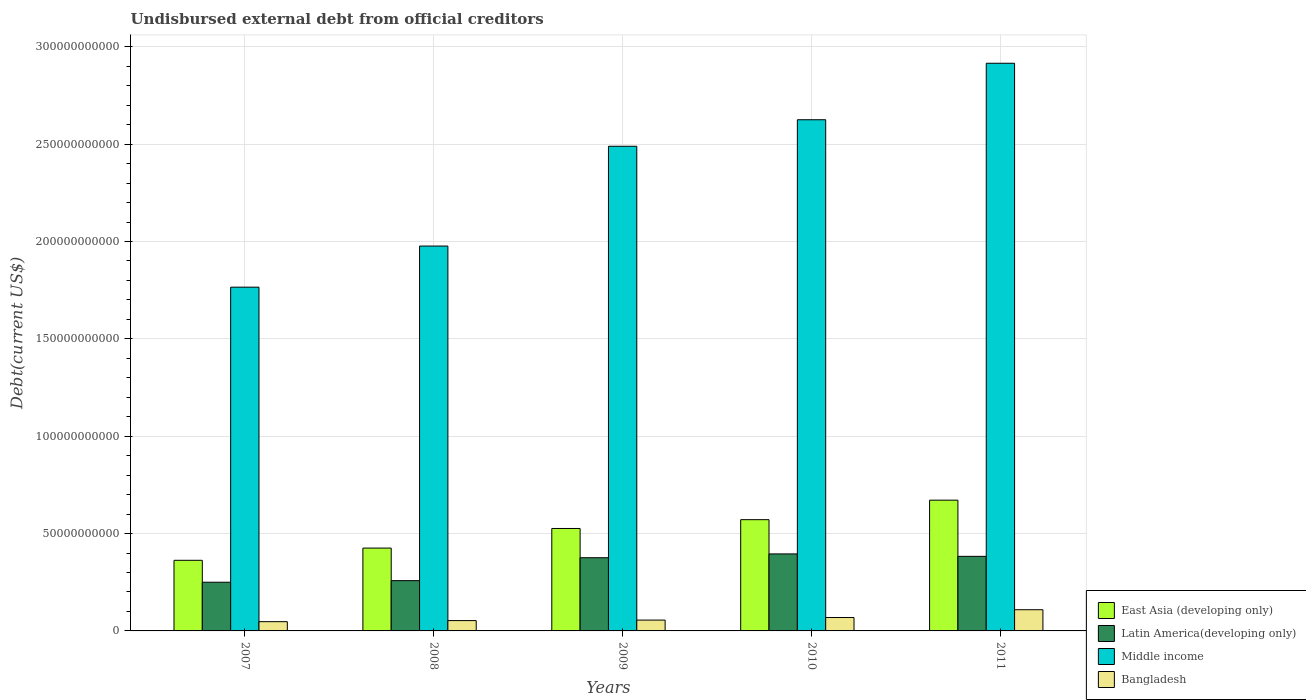How many groups of bars are there?
Keep it short and to the point. 5. How many bars are there on the 2nd tick from the right?
Offer a terse response. 4. In how many cases, is the number of bars for a given year not equal to the number of legend labels?
Ensure brevity in your answer.  0. What is the total debt in East Asia (developing only) in 2007?
Your response must be concise. 3.63e+1. Across all years, what is the maximum total debt in Latin America(developing only)?
Offer a terse response. 3.95e+1. Across all years, what is the minimum total debt in East Asia (developing only)?
Keep it short and to the point. 3.63e+1. In which year was the total debt in Middle income minimum?
Ensure brevity in your answer.  2007. What is the total total debt in Middle income in the graph?
Give a very brief answer. 1.18e+12. What is the difference between the total debt in Bangladesh in 2007 and that in 2010?
Offer a terse response. -2.13e+09. What is the difference between the total debt in East Asia (developing only) in 2011 and the total debt in Bangladesh in 2007?
Give a very brief answer. 6.24e+1. What is the average total debt in East Asia (developing only) per year?
Make the answer very short. 5.11e+1. In the year 2007, what is the difference between the total debt in Middle income and total debt in East Asia (developing only)?
Keep it short and to the point. 1.40e+11. What is the ratio of the total debt in Middle income in 2007 to that in 2010?
Give a very brief answer. 0.67. What is the difference between the highest and the second highest total debt in Bangladesh?
Offer a terse response. 4.00e+09. What is the difference between the highest and the lowest total debt in East Asia (developing only)?
Ensure brevity in your answer.  3.09e+1. Is the sum of the total debt in Bangladesh in 2010 and 2011 greater than the maximum total debt in Latin America(developing only) across all years?
Make the answer very short. No. What does the 1st bar from the left in 2008 represents?
Offer a terse response. East Asia (developing only). What does the 4th bar from the right in 2009 represents?
Keep it short and to the point. East Asia (developing only). What is the difference between two consecutive major ticks on the Y-axis?
Give a very brief answer. 5.00e+1. Does the graph contain any zero values?
Give a very brief answer. No. Where does the legend appear in the graph?
Ensure brevity in your answer.  Bottom right. How many legend labels are there?
Provide a succinct answer. 4. What is the title of the graph?
Provide a short and direct response. Undisbursed external debt from official creditors. What is the label or title of the X-axis?
Give a very brief answer. Years. What is the label or title of the Y-axis?
Keep it short and to the point. Debt(current US$). What is the Debt(current US$) in East Asia (developing only) in 2007?
Offer a very short reply. 3.63e+1. What is the Debt(current US$) in Latin America(developing only) in 2007?
Give a very brief answer. 2.50e+1. What is the Debt(current US$) in Middle income in 2007?
Ensure brevity in your answer.  1.77e+11. What is the Debt(current US$) of Bangladesh in 2007?
Make the answer very short. 4.76e+09. What is the Debt(current US$) of East Asia (developing only) in 2008?
Provide a short and direct response. 4.25e+1. What is the Debt(current US$) of Latin America(developing only) in 2008?
Your answer should be very brief. 2.58e+1. What is the Debt(current US$) in Middle income in 2008?
Offer a very short reply. 1.98e+11. What is the Debt(current US$) of Bangladesh in 2008?
Give a very brief answer. 5.31e+09. What is the Debt(current US$) of East Asia (developing only) in 2009?
Make the answer very short. 5.26e+1. What is the Debt(current US$) of Latin America(developing only) in 2009?
Provide a short and direct response. 3.76e+1. What is the Debt(current US$) in Middle income in 2009?
Your answer should be very brief. 2.49e+11. What is the Debt(current US$) of Bangladesh in 2009?
Your response must be concise. 5.57e+09. What is the Debt(current US$) in East Asia (developing only) in 2010?
Your answer should be very brief. 5.71e+1. What is the Debt(current US$) in Latin America(developing only) in 2010?
Ensure brevity in your answer.  3.95e+1. What is the Debt(current US$) in Middle income in 2010?
Your answer should be compact. 2.63e+11. What is the Debt(current US$) in Bangladesh in 2010?
Give a very brief answer. 6.88e+09. What is the Debt(current US$) of East Asia (developing only) in 2011?
Make the answer very short. 6.71e+1. What is the Debt(current US$) in Latin America(developing only) in 2011?
Provide a short and direct response. 3.83e+1. What is the Debt(current US$) of Middle income in 2011?
Give a very brief answer. 2.92e+11. What is the Debt(current US$) in Bangladesh in 2011?
Keep it short and to the point. 1.09e+1. Across all years, what is the maximum Debt(current US$) in East Asia (developing only)?
Provide a short and direct response. 6.71e+1. Across all years, what is the maximum Debt(current US$) in Latin America(developing only)?
Offer a very short reply. 3.95e+1. Across all years, what is the maximum Debt(current US$) of Middle income?
Offer a very short reply. 2.92e+11. Across all years, what is the maximum Debt(current US$) in Bangladesh?
Offer a very short reply. 1.09e+1. Across all years, what is the minimum Debt(current US$) in East Asia (developing only)?
Make the answer very short. 3.63e+1. Across all years, what is the minimum Debt(current US$) in Latin America(developing only)?
Provide a short and direct response. 2.50e+1. Across all years, what is the minimum Debt(current US$) in Middle income?
Provide a succinct answer. 1.77e+11. Across all years, what is the minimum Debt(current US$) in Bangladesh?
Provide a succinct answer. 4.76e+09. What is the total Debt(current US$) of East Asia (developing only) in the graph?
Offer a very short reply. 2.56e+11. What is the total Debt(current US$) of Latin America(developing only) in the graph?
Keep it short and to the point. 1.66e+11. What is the total Debt(current US$) of Middle income in the graph?
Provide a short and direct response. 1.18e+12. What is the total Debt(current US$) in Bangladesh in the graph?
Offer a terse response. 3.34e+1. What is the difference between the Debt(current US$) in East Asia (developing only) in 2007 and that in 2008?
Offer a very short reply. -6.27e+09. What is the difference between the Debt(current US$) in Latin America(developing only) in 2007 and that in 2008?
Your response must be concise. -8.16e+08. What is the difference between the Debt(current US$) of Middle income in 2007 and that in 2008?
Give a very brief answer. -2.11e+1. What is the difference between the Debt(current US$) in Bangladesh in 2007 and that in 2008?
Offer a very short reply. -5.49e+08. What is the difference between the Debt(current US$) of East Asia (developing only) in 2007 and that in 2009?
Provide a succinct answer. -1.63e+1. What is the difference between the Debt(current US$) in Latin America(developing only) in 2007 and that in 2009?
Provide a short and direct response. -1.26e+1. What is the difference between the Debt(current US$) in Middle income in 2007 and that in 2009?
Keep it short and to the point. -7.24e+1. What is the difference between the Debt(current US$) of Bangladesh in 2007 and that in 2009?
Keep it short and to the point. -8.10e+08. What is the difference between the Debt(current US$) in East Asia (developing only) in 2007 and that in 2010?
Your answer should be very brief. -2.09e+1. What is the difference between the Debt(current US$) in Latin America(developing only) in 2007 and that in 2010?
Your answer should be compact. -1.45e+1. What is the difference between the Debt(current US$) in Middle income in 2007 and that in 2010?
Make the answer very short. -8.60e+1. What is the difference between the Debt(current US$) in Bangladesh in 2007 and that in 2010?
Offer a terse response. -2.13e+09. What is the difference between the Debt(current US$) in East Asia (developing only) in 2007 and that in 2011?
Offer a very short reply. -3.09e+1. What is the difference between the Debt(current US$) of Latin America(developing only) in 2007 and that in 2011?
Give a very brief answer. -1.33e+1. What is the difference between the Debt(current US$) in Middle income in 2007 and that in 2011?
Your response must be concise. -1.15e+11. What is the difference between the Debt(current US$) of Bangladesh in 2007 and that in 2011?
Provide a short and direct response. -6.13e+09. What is the difference between the Debt(current US$) in East Asia (developing only) in 2008 and that in 2009?
Your answer should be very brief. -1.01e+1. What is the difference between the Debt(current US$) of Latin America(developing only) in 2008 and that in 2009?
Your answer should be compact. -1.18e+1. What is the difference between the Debt(current US$) of Middle income in 2008 and that in 2009?
Keep it short and to the point. -5.12e+1. What is the difference between the Debt(current US$) in Bangladesh in 2008 and that in 2009?
Provide a short and direct response. -2.61e+08. What is the difference between the Debt(current US$) in East Asia (developing only) in 2008 and that in 2010?
Your answer should be very brief. -1.46e+1. What is the difference between the Debt(current US$) of Latin America(developing only) in 2008 and that in 2010?
Ensure brevity in your answer.  -1.37e+1. What is the difference between the Debt(current US$) in Middle income in 2008 and that in 2010?
Ensure brevity in your answer.  -6.49e+1. What is the difference between the Debt(current US$) in Bangladesh in 2008 and that in 2010?
Ensure brevity in your answer.  -1.58e+09. What is the difference between the Debt(current US$) in East Asia (developing only) in 2008 and that in 2011?
Your answer should be very brief. -2.46e+1. What is the difference between the Debt(current US$) of Latin America(developing only) in 2008 and that in 2011?
Ensure brevity in your answer.  -1.25e+1. What is the difference between the Debt(current US$) in Middle income in 2008 and that in 2011?
Provide a succinct answer. -9.39e+1. What is the difference between the Debt(current US$) in Bangladesh in 2008 and that in 2011?
Offer a terse response. -5.58e+09. What is the difference between the Debt(current US$) of East Asia (developing only) in 2009 and that in 2010?
Ensure brevity in your answer.  -4.53e+09. What is the difference between the Debt(current US$) in Latin America(developing only) in 2009 and that in 2010?
Ensure brevity in your answer.  -1.96e+09. What is the difference between the Debt(current US$) in Middle income in 2009 and that in 2010?
Your answer should be very brief. -1.36e+1. What is the difference between the Debt(current US$) in Bangladesh in 2009 and that in 2010?
Offer a terse response. -1.32e+09. What is the difference between the Debt(current US$) of East Asia (developing only) in 2009 and that in 2011?
Offer a very short reply. -1.45e+1. What is the difference between the Debt(current US$) in Latin America(developing only) in 2009 and that in 2011?
Keep it short and to the point. -7.08e+08. What is the difference between the Debt(current US$) of Middle income in 2009 and that in 2011?
Provide a succinct answer. -4.26e+1. What is the difference between the Debt(current US$) in Bangladesh in 2009 and that in 2011?
Give a very brief answer. -5.32e+09. What is the difference between the Debt(current US$) of East Asia (developing only) in 2010 and that in 2011?
Make the answer very short. -1.00e+1. What is the difference between the Debt(current US$) of Latin America(developing only) in 2010 and that in 2011?
Your answer should be compact. 1.25e+09. What is the difference between the Debt(current US$) in Middle income in 2010 and that in 2011?
Provide a succinct answer. -2.90e+1. What is the difference between the Debt(current US$) of Bangladesh in 2010 and that in 2011?
Your answer should be compact. -4.00e+09. What is the difference between the Debt(current US$) of East Asia (developing only) in 2007 and the Debt(current US$) of Latin America(developing only) in 2008?
Provide a short and direct response. 1.04e+1. What is the difference between the Debt(current US$) of East Asia (developing only) in 2007 and the Debt(current US$) of Middle income in 2008?
Offer a terse response. -1.61e+11. What is the difference between the Debt(current US$) in East Asia (developing only) in 2007 and the Debt(current US$) in Bangladesh in 2008?
Provide a succinct answer. 3.10e+1. What is the difference between the Debt(current US$) in Latin America(developing only) in 2007 and the Debt(current US$) in Middle income in 2008?
Your answer should be very brief. -1.73e+11. What is the difference between the Debt(current US$) in Latin America(developing only) in 2007 and the Debt(current US$) in Bangladesh in 2008?
Give a very brief answer. 1.97e+1. What is the difference between the Debt(current US$) in Middle income in 2007 and the Debt(current US$) in Bangladesh in 2008?
Your answer should be very brief. 1.71e+11. What is the difference between the Debt(current US$) in East Asia (developing only) in 2007 and the Debt(current US$) in Latin America(developing only) in 2009?
Your answer should be very brief. -1.32e+09. What is the difference between the Debt(current US$) of East Asia (developing only) in 2007 and the Debt(current US$) of Middle income in 2009?
Your answer should be compact. -2.13e+11. What is the difference between the Debt(current US$) in East Asia (developing only) in 2007 and the Debt(current US$) in Bangladesh in 2009?
Offer a terse response. 3.07e+1. What is the difference between the Debt(current US$) in Latin America(developing only) in 2007 and the Debt(current US$) in Middle income in 2009?
Provide a succinct answer. -2.24e+11. What is the difference between the Debt(current US$) of Latin America(developing only) in 2007 and the Debt(current US$) of Bangladesh in 2009?
Offer a very short reply. 1.94e+1. What is the difference between the Debt(current US$) in Middle income in 2007 and the Debt(current US$) in Bangladesh in 2009?
Offer a very short reply. 1.71e+11. What is the difference between the Debt(current US$) of East Asia (developing only) in 2007 and the Debt(current US$) of Latin America(developing only) in 2010?
Your answer should be very brief. -3.28e+09. What is the difference between the Debt(current US$) in East Asia (developing only) in 2007 and the Debt(current US$) in Middle income in 2010?
Your answer should be compact. -2.26e+11. What is the difference between the Debt(current US$) in East Asia (developing only) in 2007 and the Debt(current US$) in Bangladesh in 2010?
Make the answer very short. 2.94e+1. What is the difference between the Debt(current US$) of Latin America(developing only) in 2007 and the Debt(current US$) of Middle income in 2010?
Ensure brevity in your answer.  -2.38e+11. What is the difference between the Debt(current US$) in Latin America(developing only) in 2007 and the Debt(current US$) in Bangladesh in 2010?
Offer a terse response. 1.81e+1. What is the difference between the Debt(current US$) in Middle income in 2007 and the Debt(current US$) in Bangladesh in 2010?
Your answer should be compact. 1.70e+11. What is the difference between the Debt(current US$) of East Asia (developing only) in 2007 and the Debt(current US$) of Latin America(developing only) in 2011?
Your answer should be very brief. -2.03e+09. What is the difference between the Debt(current US$) in East Asia (developing only) in 2007 and the Debt(current US$) in Middle income in 2011?
Keep it short and to the point. -2.55e+11. What is the difference between the Debt(current US$) in East Asia (developing only) in 2007 and the Debt(current US$) in Bangladesh in 2011?
Offer a very short reply. 2.54e+1. What is the difference between the Debt(current US$) of Latin America(developing only) in 2007 and the Debt(current US$) of Middle income in 2011?
Provide a succinct answer. -2.67e+11. What is the difference between the Debt(current US$) in Latin America(developing only) in 2007 and the Debt(current US$) in Bangladesh in 2011?
Your answer should be very brief. 1.41e+1. What is the difference between the Debt(current US$) of Middle income in 2007 and the Debt(current US$) of Bangladesh in 2011?
Keep it short and to the point. 1.66e+11. What is the difference between the Debt(current US$) in East Asia (developing only) in 2008 and the Debt(current US$) in Latin America(developing only) in 2009?
Provide a succinct answer. 4.95e+09. What is the difference between the Debt(current US$) of East Asia (developing only) in 2008 and the Debt(current US$) of Middle income in 2009?
Offer a very short reply. -2.06e+11. What is the difference between the Debt(current US$) of East Asia (developing only) in 2008 and the Debt(current US$) of Bangladesh in 2009?
Your answer should be compact. 3.70e+1. What is the difference between the Debt(current US$) of Latin America(developing only) in 2008 and the Debt(current US$) of Middle income in 2009?
Offer a terse response. -2.23e+11. What is the difference between the Debt(current US$) in Latin America(developing only) in 2008 and the Debt(current US$) in Bangladesh in 2009?
Provide a short and direct response. 2.03e+1. What is the difference between the Debt(current US$) of Middle income in 2008 and the Debt(current US$) of Bangladesh in 2009?
Ensure brevity in your answer.  1.92e+11. What is the difference between the Debt(current US$) of East Asia (developing only) in 2008 and the Debt(current US$) of Latin America(developing only) in 2010?
Offer a terse response. 2.99e+09. What is the difference between the Debt(current US$) of East Asia (developing only) in 2008 and the Debt(current US$) of Middle income in 2010?
Offer a terse response. -2.20e+11. What is the difference between the Debt(current US$) in East Asia (developing only) in 2008 and the Debt(current US$) in Bangladesh in 2010?
Give a very brief answer. 3.57e+1. What is the difference between the Debt(current US$) of Latin America(developing only) in 2008 and the Debt(current US$) of Middle income in 2010?
Offer a very short reply. -2.37e+11. What is the difference between the Debt(current US$) in Latin America(developing only) in 2008 and the Debt(current US$) in Bangladesh in 2010?
Your response must be concise. 1.89e+1. What is the difference between the Debt(current US$) in Middle income in 2008 and the Debt(current US$) in Bangladesh in 2010?
Your answer should be very brief. 1.91e+11. What is the difference between the Debt(current US$) in East Asia (developing only) in 2008 and the Debt(current US$) in Latin America(developing only) in 2011?
Keep it short and to the point. 4.25e+09. What is the difference between the Debt(current US$) in East Asia (developing only) in 2008 and the Debt(current US$) in Middle income in 2011?
Ensure brevity in your answer.  -2.49e+11. What is the difference between the Debt(current US$) of East Asia (developing only) in 2008 and the Debt(current US$) of Bangladesh in 2011?
Keep it short and to the point. 3.17e+1. What is the difference between the Debt(current US$) of Latin America(developing only) in 2008 and the Debt(current US$) of Middle income in 2011?
Your response must be concise. -2.66e+11. What is the difference between the Debt(current US$) of Latin America(developing only) in 2008 and the Debt(current US$) of Bangladesh in 2011?
Provide a succinct answer. 1.49e+1. What is the difference between the Debt(current US$) of Middle income in 2008 and the Debt(current US$) of Bangladesh in 2011?
Your answer should be compact. 1.87e+11. What is the difference between the Debt(current US$) of East Asia (developing only) in 2009 and the Debt(current US$) of Latin America(developing only) in 2010?
Offer a very short reply. 1.31e+1. What is the difference between the Debt(current US$) of East Asia (developing only) in 2009 and the Debt(current US$) of Middle income in 2010?
Provide a short and direct response. -2.10e+11. What is the difference between the Debt(current US$) in East Asia (developing only) in 2009 and the Debt(current US$) in Bangladesh in 2010?
Give a very brief answer. 4.57e+1. What is the difference between the Debt(current US$) in Latin America(developing only) in 2009 and the Debt(current US$) in Middle income in 2010?
Your answer should be compact. -2.25e+11. What is the difference between the Debt(current US$) in Latin America(developing only) in 2009 and the Debt(current US$) in Bangladesh in 2010?
Provide a succinct answer. 3.07e+1. What is the difference between the Debt(current US$) of Middle income in 2009 and the Debt(current US$) of Bangladesh in 2010?
Make the answer very short. 2.42e+11. What is the difference between the Debt(current US$) of East Asia (developing only) in 2009 and the Debt(current US$) of Latin America(developing only) in 2011?
Your answer should be very brief. 1.43e+1. What is the difference between the Debt(current US$) in East Asia (developing only) in 2009 and the Debt(current US$) in Middle income in 2011?
Offer a very short reply. -2.39e+11. What is the difference between the Debt(current US$) of East Asia (developing only) in 2009 and the Debt(current US$) of Bangladesh in 2011?
Your answer should be compact. 4.17e+1. What is the difference between the Debt(current US$) of Latin America(developing only) in 2009 and the Debt(current US$) of Middle income in 2011?
Your response must be concise. -2.54e+11. What is the difference between the Debt(current US$) of Latin America(developing only) in 2009 and the Debt(current US$) of Bangladesh in 2011?
Provide a succinct answer. 2.67e+1. What is the difference between the Debt(current US$) of Middle income in 2009 and the Debt(current US$) of Bangladesh in 2011?
Keep it short and to the point. 2.38e+11. What is the difference between the Debt(current US$) in East Asia (developing only) in 2010 and the Debt(current US$) in Latin America(developing only) in 2011?
Your response must be concise. 1.88e+1. What is the difference between the Debt(current US$) in East Asia (developing only) in 2010 and the Debt(current US$) in Middle income in 2011?
Provide a succinct answer. -2.34e+11. What is the difference between the Debt(current US$) in East Asia (developing only) in 2010 and the Debt(current US$) in Bangladesh in 2011?
Ensure brevity in your answer.  4.63e+1. What is the difference between the Debt(current US$) in Latin America(developing only) in 2010 and the Debt(current US$) in Middle income in 2011?
Offer a terse response. -2.52e+11. What is the difference between the Debt(current US$) in Latin America(developing only) in 2010 and the Debt(current US$) in Bangladesh in 2011?
Offer a very short reply. 2.87e+1. What is the difference between the Debt(current US$) of Middle income in 2010 and the Debt(current US$) of Bangladesh in 2011?
Ensure brevity in your answer.  2.52e+11. What is the average Debt(current US$) in East Asia (developing only) per year?
Your response must be concise. 5.11e+1. What is the average Debt(current US$) in Latin America(developing only) per year?
Your answer should be very brief. 3.33e+1. What is the average Debt(current US$) in Middle income per year?
Keep it short and to the point. 2.35e+11. What is the average Debt(current US$) of Bangladesh per year?
Your answer should be compact. 6.68e+09. In the year 2007, what is the difference between the Debt(current US$) in East Asia (developing only) and Debt(current US$) in Latin America(developing only)?
Ensure brevity in your answer.  1.13e+1. In the year 2007, what is the difference between the Debt(current US$) in East Asia (developing only) and Debt(current US$) in Middle income?
Ensure brevity in your answer.  -1.40e+11. In the year 2007, what is the difference between the Debt(current US$) of East Asia (developing only) and Debt(current US$) of Bangladesh?
Give a very brief answer. 3.15e+1. In the year 2007, what is the difference between the Debt(current US$) in Latin America(developing only) and Debt(current US$) in Middle income?
Offer a very short reply. -1.52e+11. In the year 2007, what is the difference between the Debt(current US$) of Latin America(developing only) and Debt(current US$) of Bangladesh?
Make the answer very short. 2.02e+1. In the year 2007, what is the difference between the Debt(current US$) in Middle income and Debt(current US$) in Bangladesh?
Offer a terse response. 1.72e+11. In the year 2008, what is the difference between the Debt(current US$) in East Asia (developing only) and Debt(current US$) in Latin America(developing only)?
Offer a very short reply. 1.67e+1. In the year 2008, what is the difference between the Debt(current US$) in East Asia (developing only) and Debt(current US$) in Middle income?
Offer a very short reply. -1.55e+11. In the year 2008, what is the difference between the Debt(current US$) of East Asia (developing only) and Debt(current US$) of Bangladesh?
Give a very brief answer. 3.72e+1. In the year 2008, what is the difference between the Debt(current US$) in Latin America(developing only) and Debt(current US$) in Middle income?
Provide a succinct answer. -1.72e+11. In the year 2008, what is the difference between the Debt(current US$) of Latin America(developing only) and Debt(current US$) of Bangladesh?
Ensure brevity in your answer.  2.05e+1. In the year 2008, what is the difference between the Debt(current US$) of Middle income and Debt(current US$) of Bangladesh?
Offer a very short reply. 1.92e+11. In the year 2009, what is the difference between the Debt(current US$) in East Asia (developing only) and Debt(current US$) in Latin America(developing only)?
Offer a terse response. 1.50e+1. In the year 2009, what is the difference between the Debt(current US$) in East Asia (developing only) and Debt(current US$) in Middle income?
Give a very brief answer. -1.96e+11. In the year 2009, what is the difference between the Debt(current US$) of East Asia (developing only) and Debt(current US$) of Bangladesh?
Provide a short and direct response. 4.70e+1. In the year 2009, what is the difference between the Debt(current US$) of Latin America(developing only) and Debt(current US$) of Middle income?
Offer a terse response. -2.11e+11. In the year 2009, what is the difference between the Debt(current US$) of Latin America(developing only) and Debt(current US$) of Bangladesh?
Make the answer very short. 3.20e+1. In the year 2009, what is the difference between the Debt(current US$) in Middle income and Debt(current US$) in Bangladesh?
Ensure brevity in your answer.  2.43e+11. In the year 2010, what is the difference between the Debt(current US$) of East Asia (developing only) and Debt(current US$) of Latin America(developing only)?
Keep it short and to the point. 1.76e+1. In the year 2010, what is the difference between the Debt(current US$) in East Asia (developing only) and Debt(current US$) in Middle income?
Provide a short and direct response. -2.05e+11. In the year 2010, what is the difference between the Debt(current US$) of East Asia (developing only) and Debt(current US$) of Bangladesh?
Make the answer very short. 5.03e+1. In the year 2010, what is the difference between the Debt(current US$) of Latin America(developing only) and Debt(current US$) of Middle income?
Your answer should be very brief. -2.23e+11. In the year 2010, what is the difference between the Debt(current US$) of Latin America(developing only) and Debt(current US$) of Bangladesh?
Your answer should be very brief. 3.27e+1. In the year 2010, what is the difference between the Debt(current US$) in Middle income and Debt(current US$) in Bangladesh?
Your answer should be compact. 2.56e+11. In the year 2011, what is the difference between the Debt(current US$) of East Asia (developing only) and Debt(current US$) of Latin America(developing only)?
Provide a succinct answer. 2.89e+1. In the year 2011, what is the difference between the Debt(current US$) in East Asia (developing only) and Debt(current US$) in Middle income?
Provide a succinct answer. -2.24e+11. In the year 2011, what is the difference between the Debt(current US$) of East Asia (developing only) and Debt(current US$) of Bangladesh?
Provide a short and direct response. 5.63e+1. In the year 2011, what is the difference between the Debt(current US$) of Latin America(developing only) and Debt(current US$) of Middle income?
Give a very brief answer. -2.53e+11. In the year 2011, what is the difference between the Debt(current US$) in Latin America(developing only) and Debt(current US$) in Bangladesh?
Provide a succinct answer. 2.74e+1. In the year 2011, what is the difference between the Debt(current US$) in Middle income and Debt(current US$) in Bangladesh?
Offer a terse response. 2.81e+11. What is the ratio of the Debt(current US$) in East Asia (developing only) in 2007 to that in 2008?
Provide a short and direct response. 0.85. What is the ratio of the Debt(current US$) of Latin America(developing only) in 2007 to that in 2008?
Your answer should be very brief. 0.97. What is the ratio of the Debt(current US$) in Middle income in 2007 to that in 2008?
Provide a short and direct response. 0.89. What is the ratio of the Debt(current US$) of Bangladesh in 2007 to that in 2008?
Offer a terse response. 0.9. What is the ratio of the Debt(current US$) of East Asia (developing only) in 2007 to that in 2009?
Provide a short and direct response. 0.69. What is the ratio of the Debt(current US$) in Latin America(developing only) in 2007 to that in 2009?
Keep it short and to the point. 0.67. What is the ratio of the Debt(current US$) in Middle income in 2007 to that in 2009?
Your answer should be very brief. 0.71. What is the ratio of the Debt(current US$) of Bangladesh in 2007 to that in 2009?
Provide a short and direct response. 0.85. What is the ratio of the Debt(current US$) in East Asia (developing only) in 2007 to that in 2010?
Your answer should be very brief. 0.63. What is the ratio of the Debt(current US$) of Latin America(developing only) in 2007 to that in 2010?
Offer a terse response. 0.63. What is the ratio of the Debt(current US$) in Middle income in 2007 to that in 2010?
Your response must be concise. 0.67. What is the ratio of the Debt(current US$) in Bangladesh in 2007 to that in 2010?
Your answer should be very brief. 0.69. What is the ratio of the Debt(current US$) in East Asia (developing only) in 2007 to that in 2011?
Provide a succinct answer. 0.54. What is the ratio of the Debt(current US$) of Latin America(developing only) in 2007 to that in 2011?
Provide a succinct answer. 0.65. What is the ratio of the Debt(current US$) in Middle income in 2007 to that in 2011?
Ensure brevity in your answer.  0.61. What is the ratio of the Debt(current US$) of Bangladesh in 2007 to that in 2011?
Ensure brevity in your answer.  0.44. What is the ratio of the Debt(current US$) of East Asia (developing only) in 2008 to that in 2009?
Your answer should be very brief. 0.81. What is the ratio of the Debt(current US$) of Latin America(developing only) in 2008 to that in 2009?
Ensure brevity in your answer.  0.69. What is the ratio of the Debt(current US$) in Middle income in 2008 to that in 2009?
Give a very brief answer. 0.79. What is the ratio of the Debt(current US$) in Bangladesh in 2008 to that in 2009?
Provide a short and direct response. 0.95. What is the ratio of the Debt(current US$) in East Asia (developing only) in 2008 to that in 2010?
Your response must be concise. 0.74. What is the ratio of the Debt(current US$) in Latin America(developing only) in 2008 to that in 2010?
Ensure brevity in your answer.  0.65. What is the ratio of the Debt(current US$) in Middle income in 2008 to that in 2010?
Your answer should be very brief. 0.75. What is the ratio of the Debt(current US$) in Bangladesh in 2008 to that in 2010?
Provide a succinct answer. 0.77. What is the ratio of the Debt(current US$) in East Asia (developing only) in 2008 to that in 2011?
Your answer should be very brief. 0.63. What is the ratio of the Debt(current US$) in Latin America(developing only) in 2008 to that in 2011?
Keep it short and to the point. 0.67. What is the ratio of the Debt(current US$) in Middle income in 2008 to that in 2011?
Offer a very short reply. 0.68. What is the ratio of the Debt(current US$) in Bangladesh in 2008 to that in 2011?
Your answer should be very brief. 0.49. What is the ratio of the Debt(current US$) in East Asia (developing only) in 2009 to that in 2010?
Give a very brief answer. 0.92. What is the ratio of the Debt(current US$) in Latin America(developing only) in 2009 to that in 2010?
Provide a succinct answer. 0.95. What is the ratio of the Debt(current US$) of Middle income in 2009 to that in 2010?
Offer a terse response. 0.95. What is the ratio of the Debt(current US$) in Bangladesh in 2009 to that in 2010?
Your answer should be very brief. 0.81. What is the ratio of the Debt(current US$) in East Asia (developing only) in 2009 to that in 2011?
Give a very brief answer. 0.78. What is the ratio of the Debt(current US$) of Latin America(developing only) in 2009 to that in 2011?
Keep it short and to the point. 0.98. What is the ratio of the Debt(current US$) in Middle income in 2009 to that in 2011?
Make the answer very short. 0.85. What is the ratio of the Debt(current US$) in Bangladesh in 2009 to that in 2011?
Your response must be concise. 0.51. What is the ratio of the Debt(current US$) in East Asia (developing only) in 2010 to that in 2011?
Give a very brief answer. 0.85. What is the ratio of the Debt(current US$) in Latin America(developing only) in 2010 to that in 2011?
Provide a short and direct response. 1.03. What is the ratio of the Debt(current US$) in Middle income in 2010 to that in 2011?
Give a very brief answer. 0.9. What is the ratio of the Debt(current US$) in Bangladesh in 2010 to that in 2011?
Your response must be concise. 0.63. What is the difference between the highest and the second highest Debt(current US$) of East Asia (developing only)?
Provide a short and direct response. 1.00e+1. What is the difference between the highest and the second highest Debt(current US$) of Latin America(developing only)?
Your answer should be very brief. 1.25e+09. What is the difference between the highest and the second highest Debt(current US$) in Middle income?
Provide a short and direct response. 2.90e+1. What is the difference between the highest and the second highest Debt(current US$) in Bangladesh?
Your answer should be very brief. 4.00e+09. What is the difference between the highest and the lowest Debt(current US$) of East Asia (developing only)?
Your answer should be compact. 3.09e+1. What is the difference between the highest and the lowest Debt(current US$) in Latin America(developing only)?
Offer a very short reply. 1.45e+1. What is the difference between the highest and the lowest Debt(current US$) of Middle income?
Provide a short and direct response. 1.15e+11. What is the difference between the highest and the lowest Debt(current US$) of Bangladesh?
Make the answer very short. 6.13e+09. 